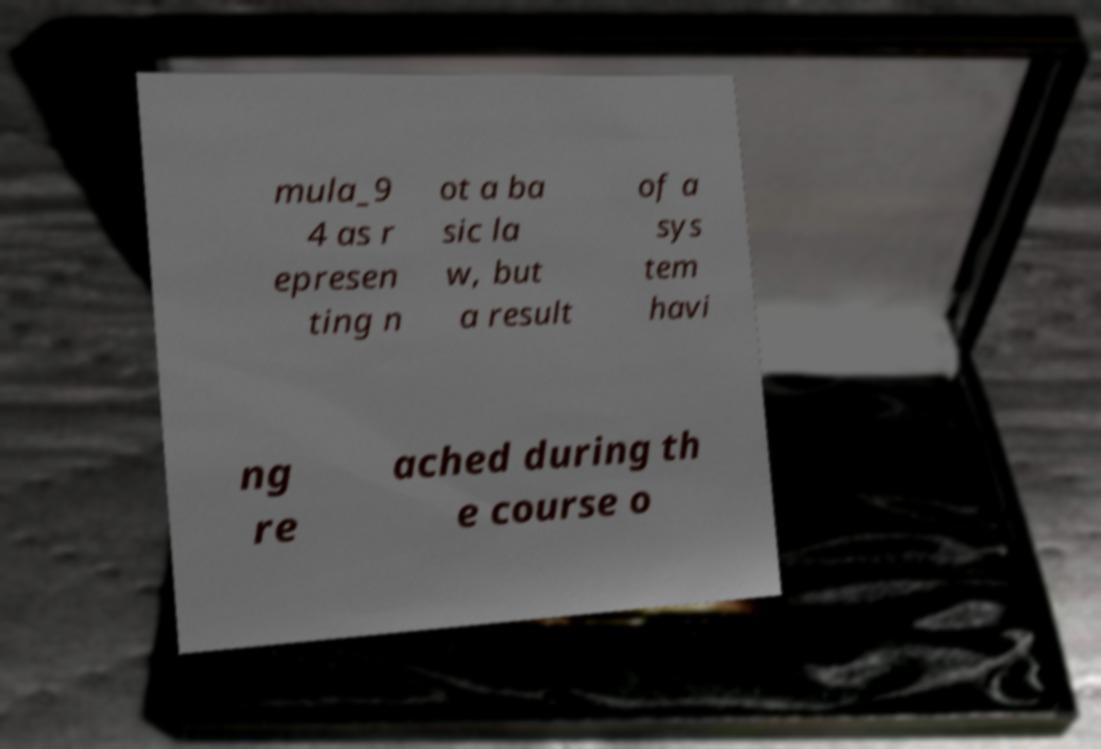Can you accurately transcribe the text from the provided image for me? mula_9 4 as r epresen ting n ot a ba sic la w, but a result of a sys tem havi ng re ached during th e course o 